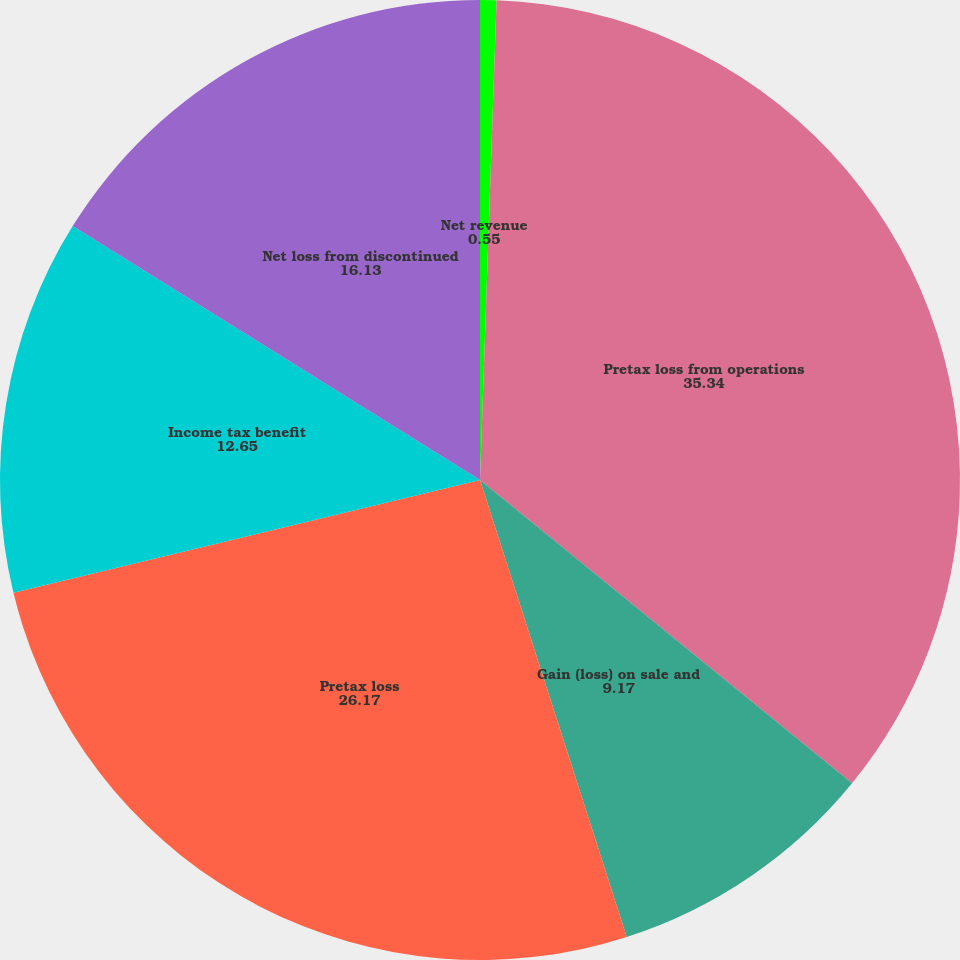<chart> <loc_0><loc_0><loc_500><loc_500><pie_chart><fcel>Net revenue<fcel>Pretax loss from operations<fcel>Gain (loss) on sale and<fcel>Pretax loss<fcel>Income tax benefit<fcel>Net loss from discontinued<nl><fcel>0.55%<fcel>35.34%<fcel>9.17%<fcel>26.17%<fcel>12.65%<fcel>16.13%<nl></chart> 